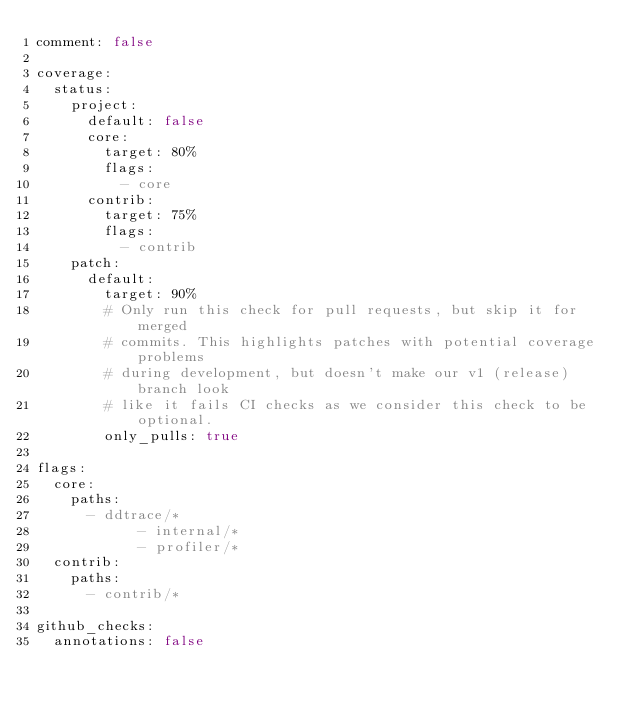<code> <loc_0><loc_0><loc_500><loc_500><_YAML_>comment: false

coverage:
  status:
    project:
      default: false
      core:
        target: 80%
        flags:
          - core
      contrib:
        target: 75%
        flags:
          - contrib
    patch:
      default:
        target: 90%
        # Only run this check for pull requests, but skip it for merged
        # commits. This highlights patches with potential coverage problems
        # during development, but doesn't make our v1 (release) branch look
        # like it fails CI checks as we consider this check to be optional.
        only_pulls: true

flags:
  core:
    paths:
      - ddtrace/*
            - internal/*
            - profiler/*
  contrib:
    paths:
      - contrib/*

github_checks:
  annotations: false
</code> 